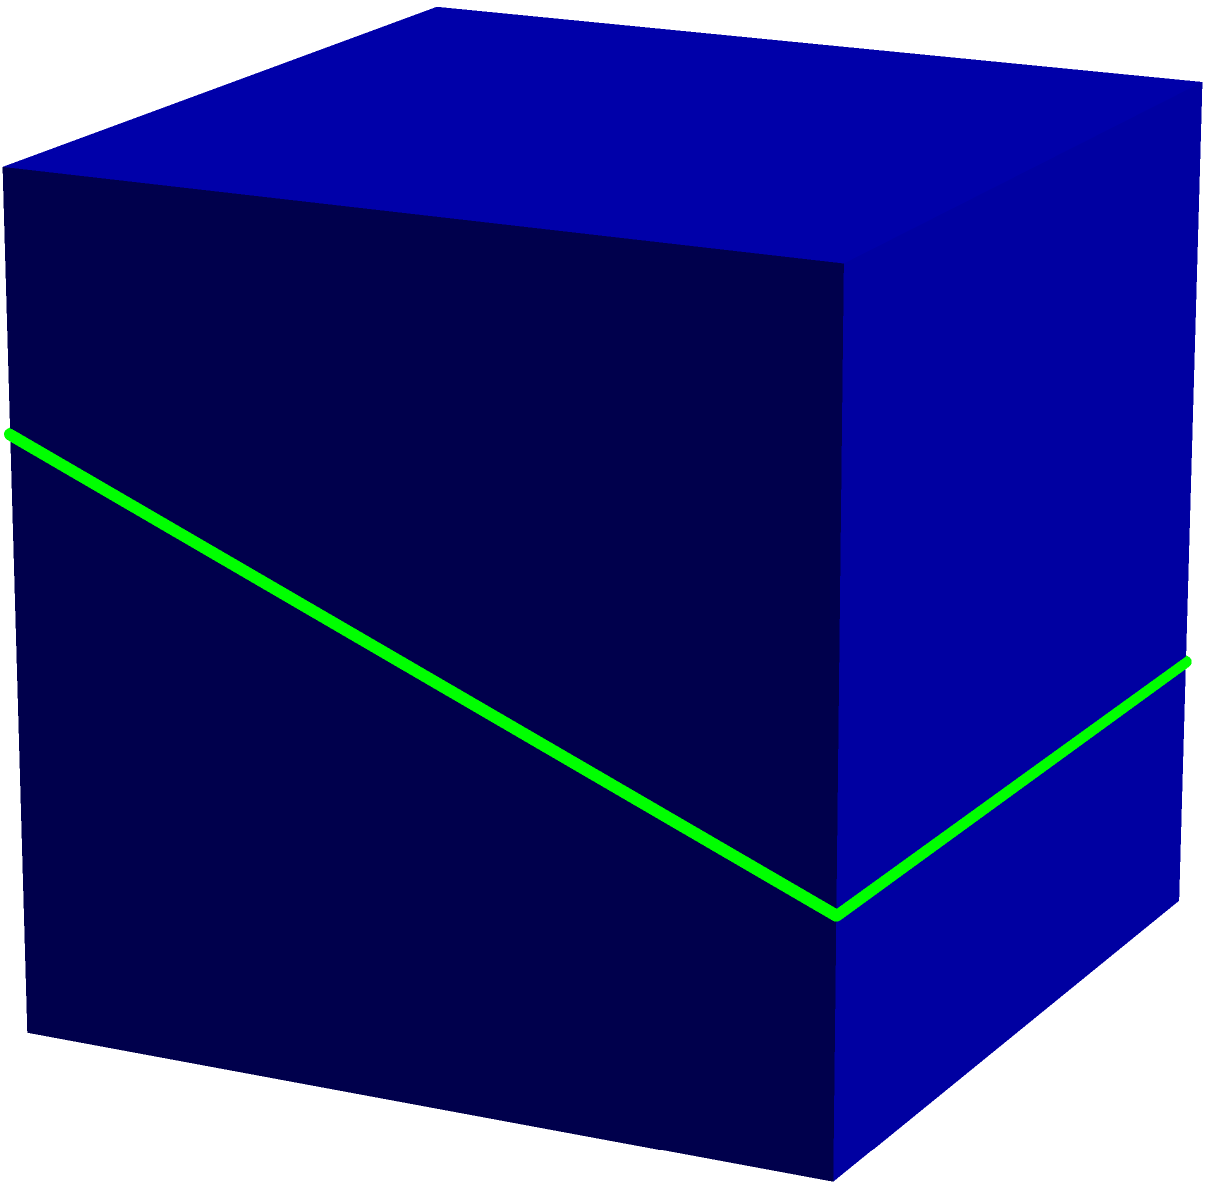As a graphic designer familiar with 3D modeling, consider a unit cube being intersected by a plane as shown in the diagram. The plane passes through points (0,0,0.7), (1,0,0.7), (1,1,0.3), and (0,1,0.3). What shape is the resulting cross-section, and how many sides does it have? To determine the shape of the cross-section, let's analyze the problem step-by-step:

1. Visualize the cube: The cube has dimensions 1x1x1, with corners at (0,0,0), (1,0,0), (0,1,0), (1,1,0), (0,0,1), (1,0,1), (0,1,1), and (1,1,1).

2. Analyze the cutting plane: The plane intersects the cube at four points:
   - (0,0,0.7) on the left edge
   - (1,0,0.7) on the right edge
   - (1,1,0.3) on the front right edge
   - (0,1,0.3) on the front left edge

3. Determine the shape:
   - The plane creates a quadrilateral cross-section because it intersects four edges of the cube.
   - The quadrilateral is not a rectangle or a square because the z-coordinates of the intersection points are not all the same.
   - The quadrilateral is not a parallelogram because the opposing edges are not parallel (they have different z-coordinates).

4. Count the sides:
   - A quadrilateral, by definition, has four sides.

Therefore, the resulting cross-section is an irregular quadrilateral with four sides.
Answer: Irregular quadrilateral with 4 sides 